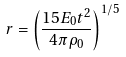Convert formula to latex. <formula><loc_0><loc_0><loc_500><loc_500>r = \left ( \frac { 1 5 E _ { 0 } t ^ { 2 } } { 4 \pi \rho _ { 0 } } \right ) ^ { 1 / 5 }</formula> 